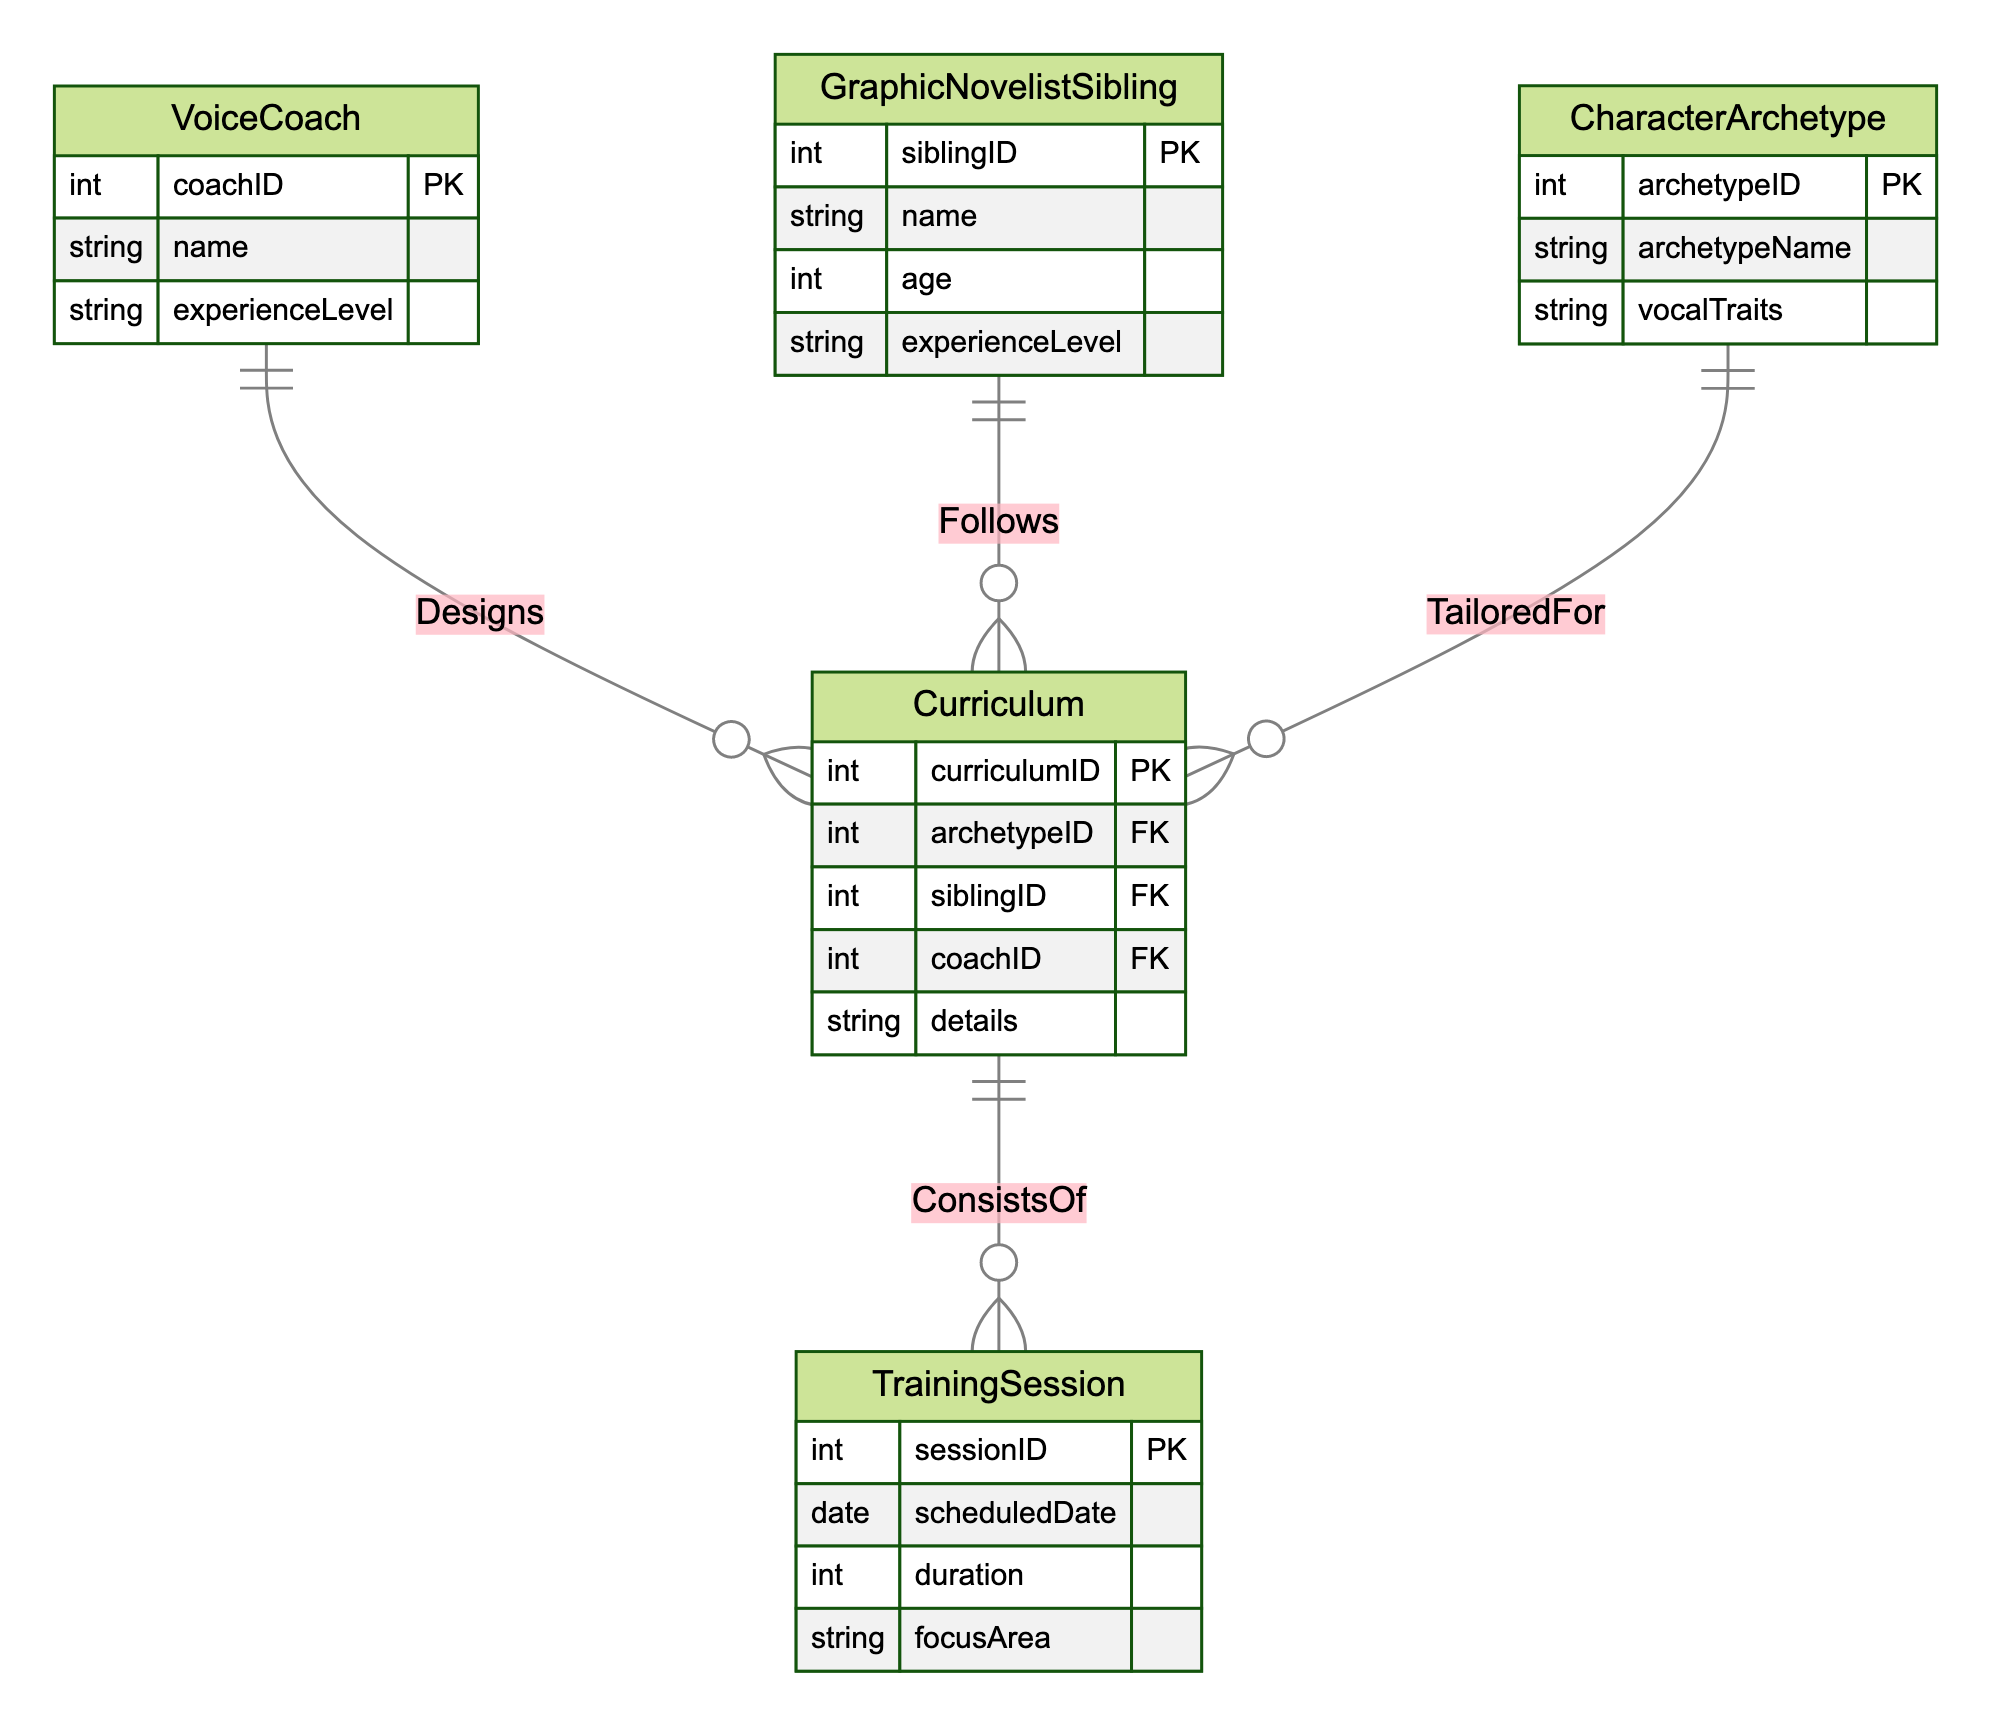What's the primary entity responsible for designing the curriculum? The diagram shows a relationship where the VoiceCoach entity has a "Designs" relationship with the Curriculum entity, indicating that the VoiceCoach is primarily responsible for designing the curriculum.
Answer: VoiceCoach How many character archetypes are tailored for the curriculum? The diagram illustrates a one-to-many relationship between CharacterArchetype and Curriculum, indicating each CharacterArchetype can be associated with multiple Curriculum instances. However, the specific number is not provided in the diagram.
Answer: Many Which entity type follows the curriculum? The relationship illustrated indicates that the GraphicNovelistSibling entity has a "Follows" relationship with the Curriculum entity, meaning that this entity type engages with the curriculum.
Answer: GraphicNovelistSibling What is the focus area in a training session? The TrainingSession entity contains an attribute called focusArea, which specifies the area of focus for each training session. This means that each training session has a defined topic or skill being trained.
Answer: focusArea How many training sessions can a curriculum consist of? The diagram indicates that each Curriculum can be associated with multiple TrainingSession instances through the "ConsistsOf" relationship, allowing for various training sessions to be linked.
Answer: Many Which entity is linked to the curriculum with a foreign key? The Curriculum entity includes several foreign keys that link it to other entities: archetypeID (CharacterArchetype), siblingID (GraphicNovelistSibling), and coachID (VoiceCoach). This indicates that all these entities connect to the Curriculum entity through respective foreign keys.
Answer: All three entities What attribute specifies the duration of a training session? The TrainingSession entity includes an attribute labeled duration, which specifically indicates the length of time allocated for each training session.
Answer: duration Is it possible for one voice coach to design multiple curriculums? The diagram demonstrates a one-to-many relationship from VoiceCoach to Curriculum, meaning a single VoiceCoach can design multiple curricular programs, supporting this possibility.
Answer: Yes What does the curriculum consist of? The diagram shows a "ConsistsOf" relationship connecting the Curriculum entity to the TrainingSession entity, indicating that each curriculum includes multiple training sessions.
Answer: TrainingSessions 